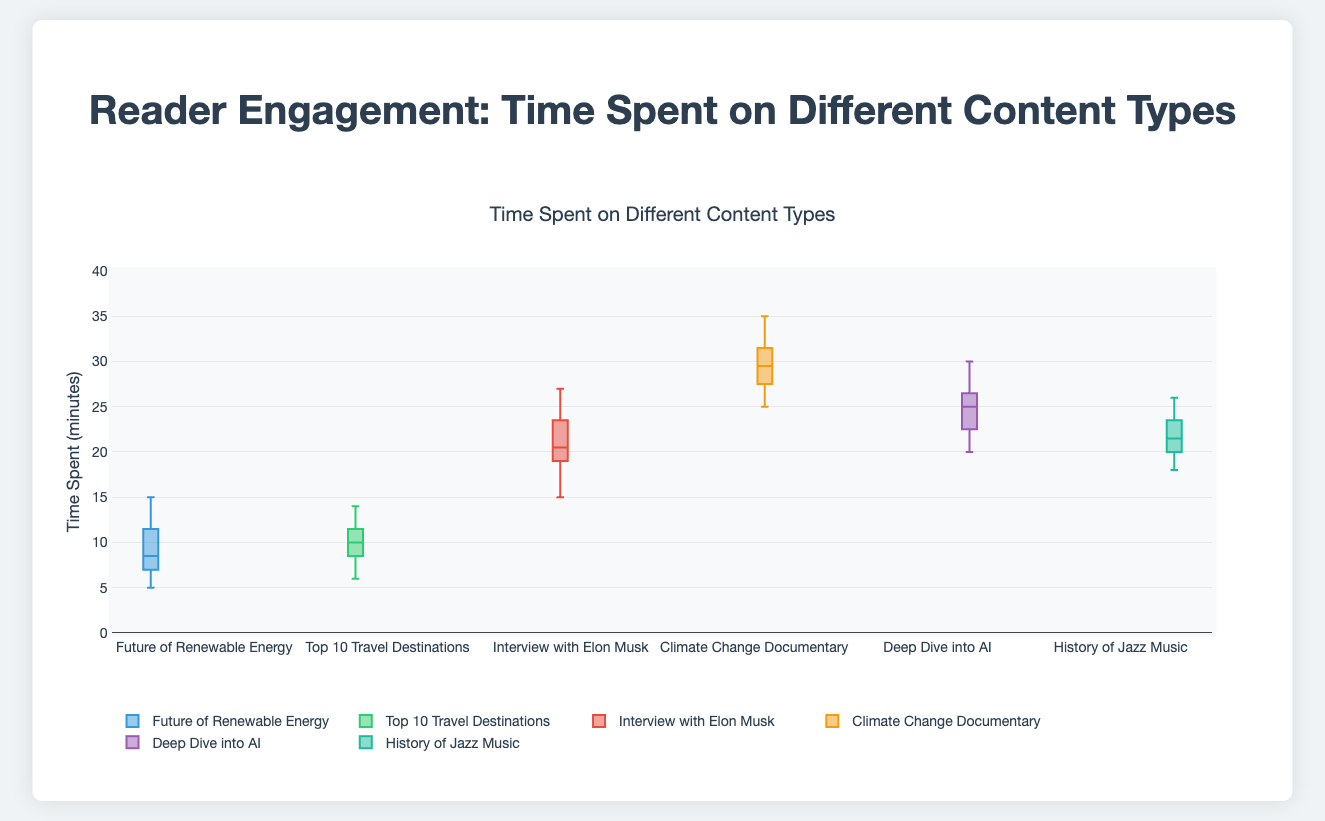What is the title of the figure? The title of the figure is located at the top and it summarizes the content of the graph. It is written as "Time Spent on Different Content Types".
Answer: Time Spent on Different Content Types What content type took the most time on average? From the figure, you can see that the median line inside each box indicates the average time spent. The content type with the highest median line is "Climate Change Documentary" under the Video category.
Answer: Climate Change Documentary How does the variance in time spent compare between the two articles? By looking at the spread of the boxes for the two articles, "The Future of Renewable Energy" and "Top 10 Travel Destinations", you can see how spread out the data points are. The former has a narrower spread compared to the latter, indicating lesser variance.
Answer: The Future of Renewable Energy has lower variance compared to Top 10 Travel Destinations Which content had the widest range of time spent by readers? The range can be observed by the distance between the whiskers (the lines extending from the box). "Climate Change Documentary" has the widest range.
Answer: Climate Change Documentary How many data points are represented in the "Deep Dive into AI" podcast? Given the nature of the box plot, you can count the individual points or refer back to the data. There are 12 data points for this podcast.
Answer: 12 What is the median time spent on "Interview with Elon Musk"? The median time is indicated by the line inside the box for "Interview with Elon Musk". You can estimate it from the graph as around 21.5 minutes.
Answer: Approximately 21.5 minutes Compare the medians of the podcasts. The median corresponds to the lines inside the boxes for the podcasts. "Deep Dive into AI" has a higher median compared to "The History of Jazz Music".
Answer: Deep Dive into AI has a higher median Which video had a higher maximum time spent: "Interview with Elon Musk" or "Climate Change Documentary"? The maximum time spent is indicated by the upper whiskers. "Climate Change Documentary" has a higher maximum time spent compared to "Interview with Elon Musk".
Answer: Climate Change Documentary What is the difference between the maximum time spent on "Top 10 Travel Destinations" and "The Future of Renewable Energy"? To find the difference, subtract the maximum time value of "The Future of Renewable Energy" from "Top 10 Travel Destinations". (14 - 15 = -1)
Answer: -1 minute What can be inferred about the interquartile range (IQR) of the two podcasts? The interquartile range is indicated by the height of the boxes. "Deep Dive into AI" has a wider box indicating a larger IQR compared to "The History of Jazz Music".
Answer: Deep Dive into AI has a larger IQR compared to The History of Jazz Music 